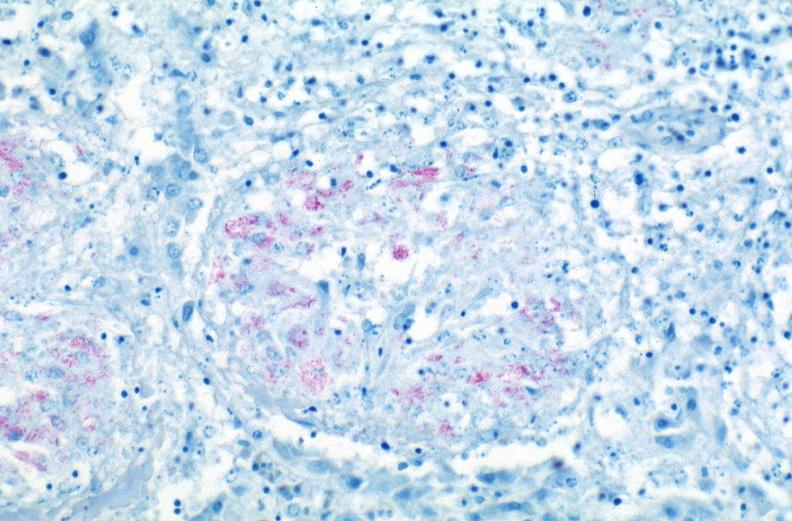where is this?
Answer the question using a single word or phrase. Lung 